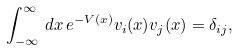<formula> <loc_0><loc_0><loc_500><loc_500>\int _ { - \infty } ^ { \infty } \, d x \, e ^ { - V \left ( x \right ) } v _ { i } ( x ) v _ { j } ( x ) = \delta _ { i j } ,</formula> 